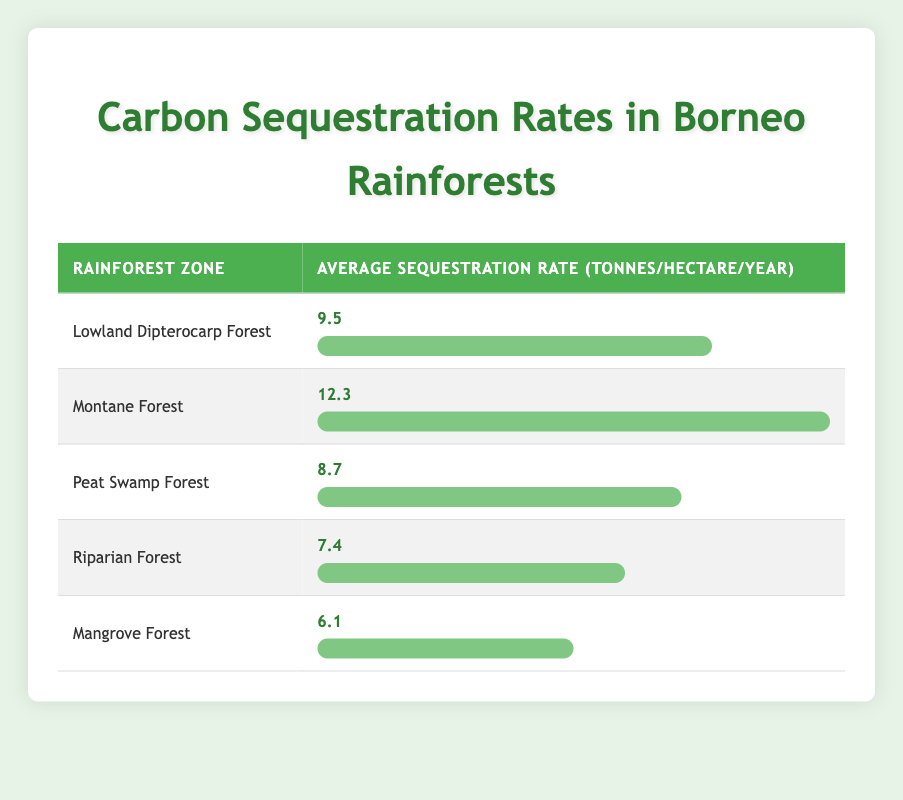What is the average carbon sequestration rate in the Montane Forest? The table states that the average sequestration rate for the Montane Forest is 12.3 tonnes per hectare per year.
Answer: 12.3 Which rainforest zone has the lowest sequestration rate? According to the table, the Mangrove Forest has the lowest average sequestration rate at 6.1 tonnes per hectare per year.
Answer: Mangrove Forest What is the difference in sequestration rates between the Lowland Dipterocarp Forest and the Riparian Forest? The sequestration rate for the Lowland Dipterocarp Forest is 9.5 tonnes per hectare per year, and for the Riparian Forest, it is 7.4 tonnes per hectare per year. The difference is 9.5 - 7.4 = 2.1 tonnes per hectare per year.
Answer: 2.1 Is the average sequestration rate of Peat Swamp Forest greater than that of Mangrove Forest? The average sequestration rate for the Peat Swamp Forest is 8.7 tonnes per hectare per year, while for the Mangrove Forest, it is 6.1 tonnes per hectare per year. Since 8.7 is greater than 6.1, the statement is true.
Answer: Yes What is the total average carbon sequestration rate for all rainforest zones listed in the table? To find the total average rate, we sum the average rates for all zones: 9.5 + 12.3 + 8.7 + 7.4 + 6.1 = 44.0 tonnes per hectare per year.
Answer: 44.0 